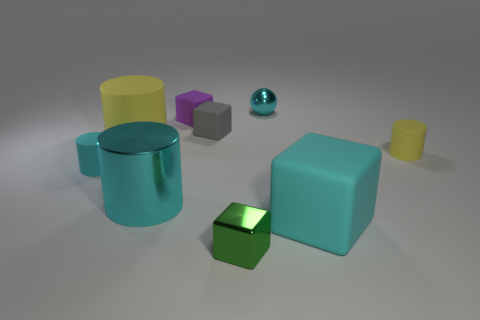What number of objects are either tiny matte cylinders or yellow objects?
Provide a succinct answer. 3. What number of tiny gray cylinders are made of the same material as the small cyan sphere?
Provide a succinct answer. 0. Are there fewer large yellow things than cyan cylinders?
Offer a terse response. Yes. Do the cyan object that is to the left of the big yellow object and the cyan sphere have the same material?
Your answer should be compact. No. How many cylinders are either tiny cyan metal things or small metal objects?
Your answer should be compact. 0. There is a object that is in front of the large cyan metallic thing and behind the tiny green metal cube; what is its shape?
Your answer should be very brief. Cube. What is the color of the small matte cylinder right of the large cylinder in front of the small matte cylinder right of the small purple thing?
Offer a terse response. Yellow. Is the number of small cyan things to the left of the green shiny thing less than the number of small cyan cylinders?
Provide a succinct answer. No. Is the shape of the metallic object on the left side of the gray object the same as the large rubber thing that is in front of the small cyan matte thing?
Offer a terse response. No. What number of things are cylinders right of the large cyan cylinder or big yellow cylinders?
Give a very brief answer. 2. 